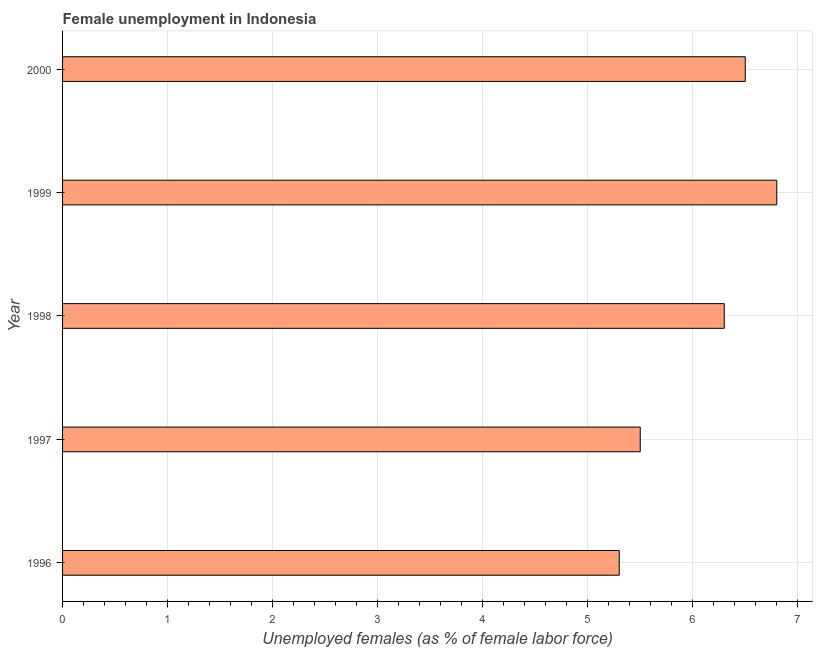What is the title of the graph?
Ensure brevity in your answer.  Female unemployment in Indonesia. What is the label or title of the X-axis?
Give a very brief answer. Unemployed females (as % of female labor force). What is the label or title of the Y-axis?
Your answer should be compact. Year. What is the unemployed females population in 2000?
Your answer should be very brief. 6.5. Across all years, what is the maximum unemployed females population?
Your answer should be compact. 6.8. Across all years, what is the minimum unemployed females population?
Your answer should be compact. 5.3. In which year was the unemployed females population maximum?
Make the answer very short. 1999. What is the sum of the unemployed females population?
Offer a very short reply. 30.4. What is the difference between the unemployed females population in 1997 and 2000?
Your response must be concise. -1. What is the average unemployed females population per year?
Keep it short and to the point. 6.08. What is the median unemployed females population?
Provide a short and direct response. 6.3. What is the ratio of the unemployed females population in 1999 to that in 2000?
Give a very brief answer. 1.05. Is the unemployed females population in 1996 less than that in 2000?
Provide a succinct answer. Yes. Is the difference between the unemployed females population in 1996 and 1998 greater than the difference between any two years?
Your response must be concise. No. What is the difference between the highest and the second highest unemployed females population?
Provide a succinct answer. 0.3. Is the sum of the unemployed females population in 1997 and 1999 greater than the maximum unemployed females population across all years?
Your answer should be compact. Yes. In how many years, is the unemployed females population greater than the average unemployed females population taken over all years?
Provide a short and direct response. 3. Are all the bars in the graph horizontal?
Provide a succinct answer. Yes. What is the Unemployed females (as % of female labor force) in 1996?
Your answer should be very brief. 5.3. What is the Unemployed females (as % of female labor force) in 1997?
Provide a short and direct response. 5.5. What is the Unemployed females (as % of female labor force) in 1998?
Your response must be concise. 6.3. What is the Unemployed females (as % of female labor force) in 1999?
Provide a succinct answer. 6.8. What is the difference between the Unemployed females (as % of female labor force) in 1996 and 1998?
Give a very brief answer. -1. What is the difference between the Unemployed females (as % of female labor force) in 1996 and 1999?
Your answer should be compact. -1.5. What is the difference between the Unemployed females (as % of female labor force) in 1996 and 2000?
Make the answer very short. -1.2. What is the difference between the Unemployed females (as % of female labor force) in 1997 and 1998?
Provide a succinct answer. -0.8. What is the difference between the Unemployed females (as % of female labor force) in 1997 and 1999?
Offer a very short reply. -1.3. What is the difference between the Unemployed females (as % of female labor force) in 1997 and 2000?
Provide a succinct answer. -1. What is the difference between the Unemployed females (as % of female labor force) in 1998 and 2000?
Keep it short and to the point. -0.2. What is the ratio of the Unemployed females (as % of female labor force) in 1996 to that in 1997?
Your response must be concise. 0.96. What is the ratio of the Unemployed females (as % of female labor force) in 1996 to that in 1998?
Your answer should be compact. 0.84. What is the ratio of the Unemployed females (as % of female labor force) in 1996 to that in 1999?
Provide a succinct answer. 0.78. What is the ratio of the Unemployed females (as % of female labor force) in 1996 to that in 2000?
Provide a succinct answer. 0.81. What is the ratio of the Unemployed females (as % of female labor force) in 1997 to that in 1998?
Ensure brevity in your answer.  0.87. What is the ratio of the Unemployed females (as % of female labor force) in 1997 to that in 1999?
Provide a succinct answer. 0.81. What is the ratio of the Unemployed females (as % of female labor force) in 1997 to that in 2000?
Provide a succinct answer. 0.85. What is the ratio of the Unemployed females (as % of female labor force) in 1998 to that in 1999?
Offer a very short reply. 0.93. What is the ratio of the Unemployed females (as % of female labor force) in 1998 to that in 2000?
Keep it short and to the point. 0.97. What is the ratio of the Unemployed females (as % of female labor force) in 1999 to that in 2000?
Ensure brevity in your answer.  1.05. 